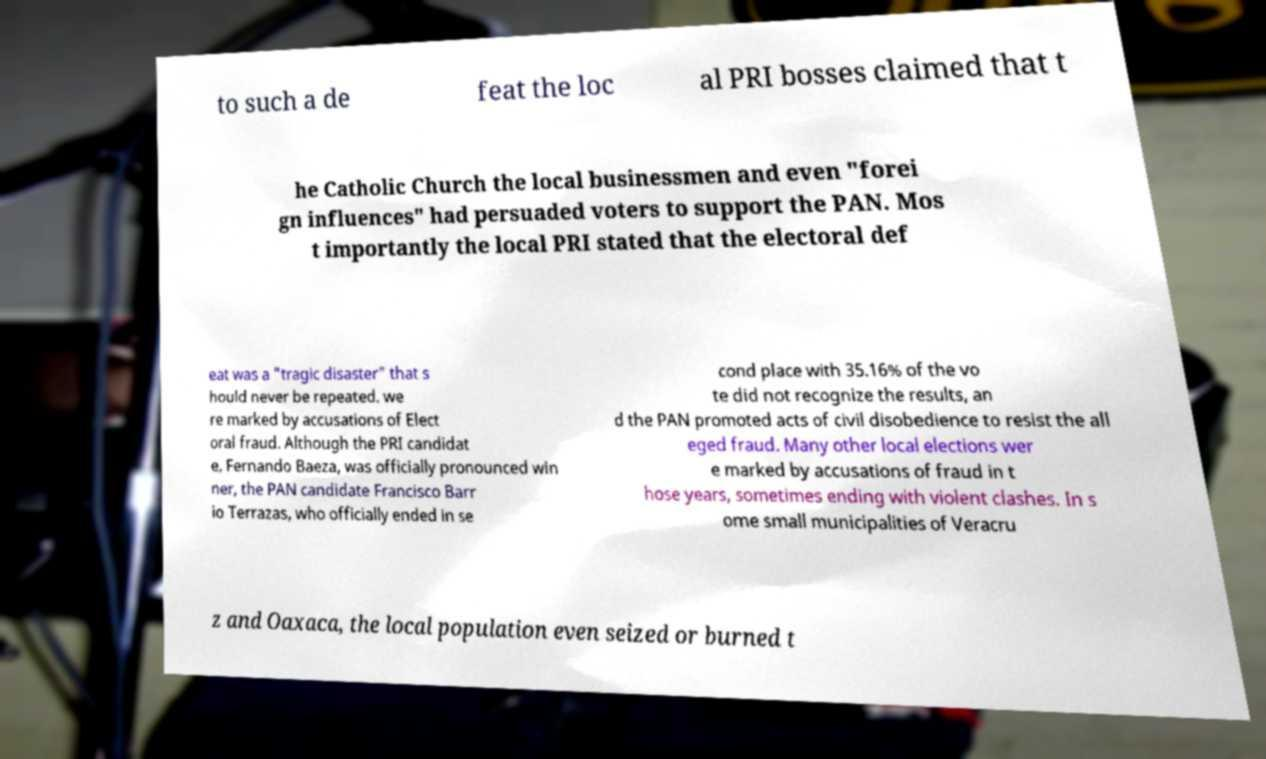Can you accurately transcribe the text from the provided image for me? to such a de feat the loc al PRI bosses claimed that t he Catholic Church the local businessmen and even "forei gn influences" had persuaded voters to support the PAN. Mos t importantly the local PRI stated that the electoral def eat was a "tragic disaster" that s hould never be repeated. we re marked by accusations of Elect oral fraud. Although the PRI candidat e, Fernando Baeza, was officially pronounced win ner, the PAN candidate Francisco Barr io Terrazas, who officially ended in se cond place with 35.16% of the vo te did not recognize the results, an d the PAN promoted acts of civil disobedience to resist the all eged fraud. Many other local elections wer e marked by accusations of fraud in t hose years, sometimes ending with violent clashes. In s ome small municipalities of Veracru z and Oaxaca, the local population even seized or burned t 